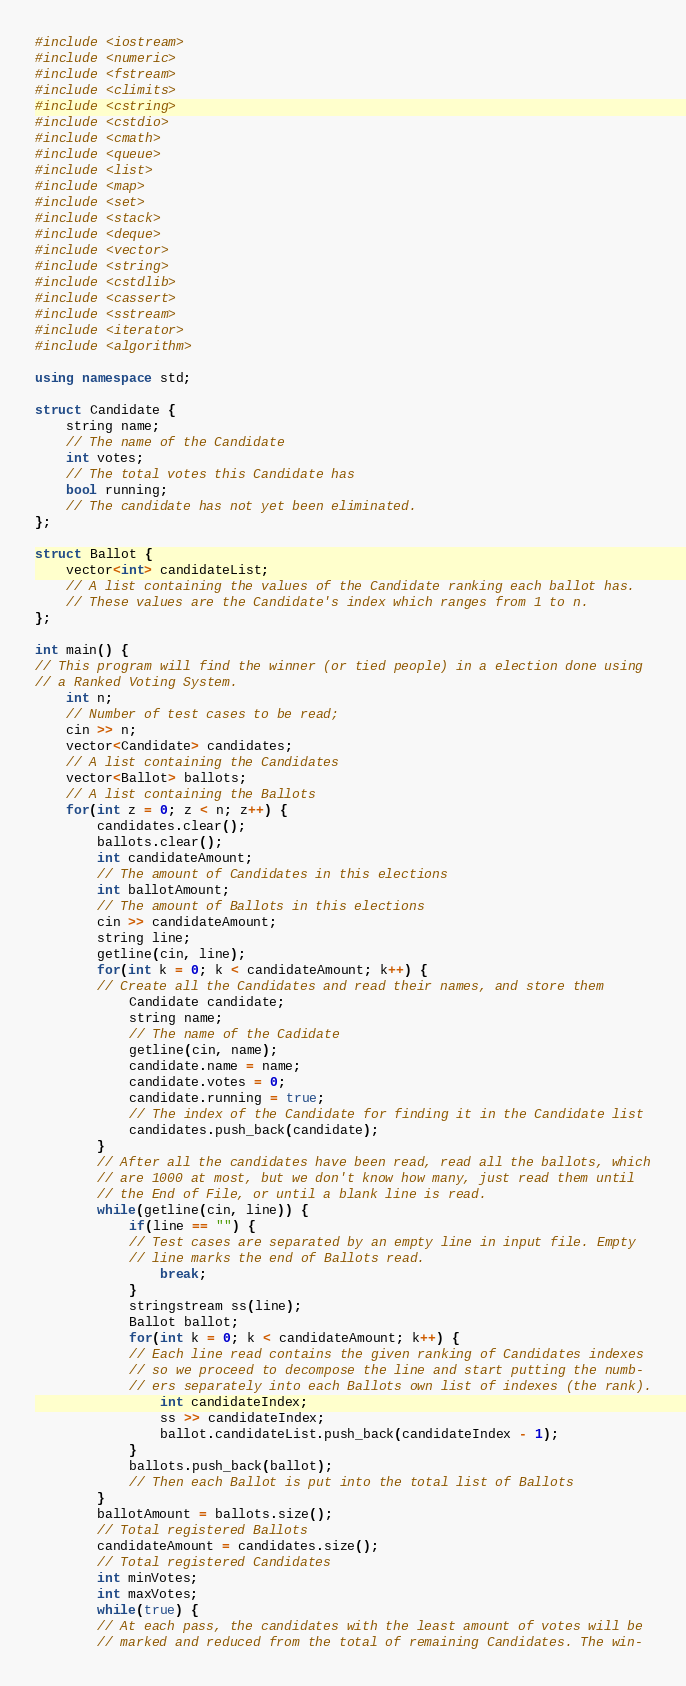Convert code to text. <code><loc_0><loc_0><loc_500><loc_500><_C++_>#include <iostream>
#include <numeric>
#include <fstream>
#include <climits>
#include <cstring>
#include <cstdio>
#include <cmath>
#include <queue>
#include <list>
#include <map>
#include <set>
#include <stack>
#include <deque>
#include <vector>
#include <string>
#include <cstdlib>
#include <cassert>
#include <sstream>
#include <iterator>
#include <algorithm>

using namespace std;

struct Candidate {
    string name;
    // The name of the Candidate
    int votes;
    // The total votes this Candidate has
    bool running;
    // The candidate has not yet been eliminated.
};

struct Ballot {
    vector<int> candidateList;
    // A list containing the values of the Candidate ranking each ballot has.
    // These values are the Candidate's index which ranges from 1 to n.
};

int main() {
// This program will find the winner (or tied people) in a election done using
// a Ranked Voting System. 
    int n;
    // Number of test cases to be read;
    cin >> n;
    vector<Candidate> candidates;
    // A list containing the Candidates
    vector<Ballot> ballots;
    // A list containing the Ballots
    for(int z = 0; z < n; z++) {
        candidates.clear();
        ballots.clear();
        int candidateAmount;
        // The amount of Candidates in this elections
        int ballotAmount;
        // The amount of Ballots in this elections
        cin >> candidateAmount;
        string line;
        getline(cin, line);
        for(int k = 0; k < candidateAmount; k++) {
        // Create all the Candidates and read their names, and store them
            Candidate candidate;
            string name;
            // The name of the Cadidate
            getline(cin, name);
            candidate.name = name;
            candidate.votes = 0;
            candidate.running = true;
            // The index of the Candidate for finding it in the Candidate list
            candidates.push_back(candidate);
        }
        // After all the candidates have been read, read all the ballots, which
        // are 1000 at most, but we don't know how many, just read them until
        // the End of File, or until a blank line is read.
        while(getline(cin, line)) {
            if(line == "") {
            // Test cases are separated by an empty line in input file. Empty
            // line marks the end of Ballots read.
                break;
            }
            stringstream ss(line);
            Ballot ballot;
            for(int k = 0; k < candidateAmount; k++) {
            // Each line read contains the given ranking of Candidates indexes
            // so we proceed to decompose the line and start putting the numb-
            // ers separately into each Ballots own list of indexes (the rank).
                int candidateIndex;
                ss >> candidateIndex;
                ballot.candidateList.push_back(candidateIndex - 1);
            }
            ballots.push_back(ballot);
            // Then each Ballot is put into the total list of Ballots
        }
        ballotAmount = ballots.size();
        // Total registered Ballots
        candidateAmount = candidates.size();
        // Total registered Candidates
        int minVotes;
        int maxVotes;
        while(true) {
        // At each pass, the candidates with the least amount of votes will be
        // marked and reduced from the total of remaining Candidates. The win-</code> 